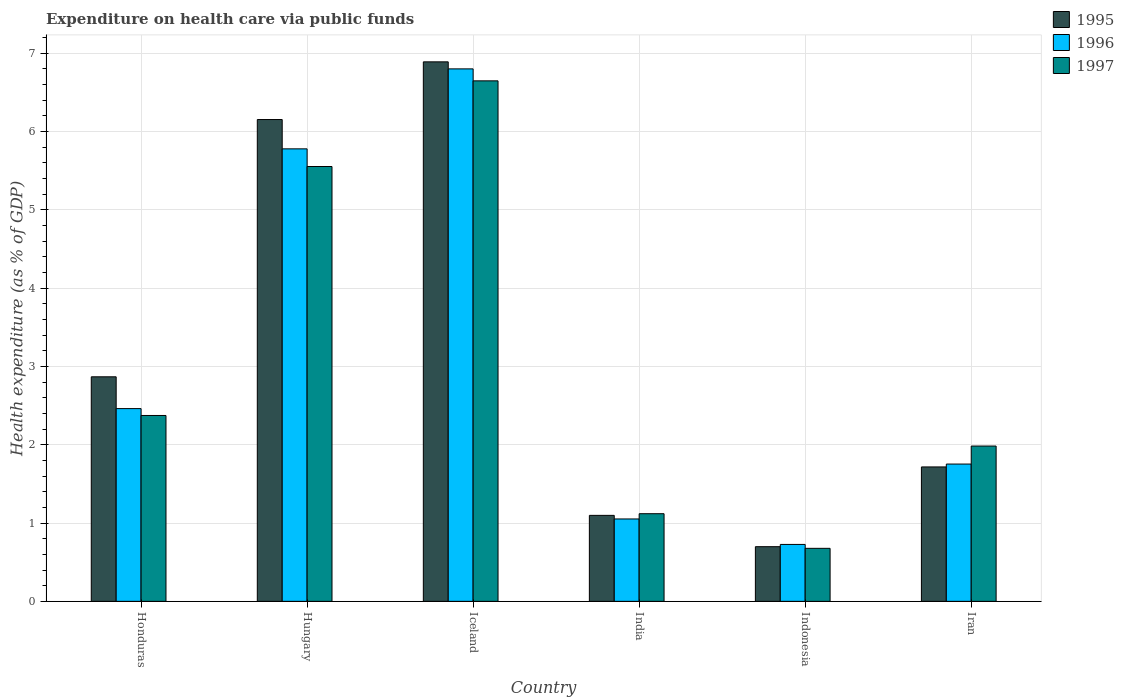How many different coloured bars are there?
Your answer should be compact. 3. How many bars are there on the 6th tick from the left?
Your answer should be compact. 3. How many bars are there on the 3rd tick from the right?
Offer a terse response. 3. What is the label of the 6th group of bars from the left?
Provide a succinct answer. Iran. In how many cases, is the number of bars for a given country not equal to the number of legend labels?
Provide a succinct answer. 0. What is the expenditure made on health care in 1996 in Hungary?
Keep it short and to the point. 5.78. Across all countries, what is the maximum expenditure made on health care in 1997?
Your response must be concise. 6.64. Across all countries, what is the minimum expenditure made on health care in 1995?
Give a very brief answer. 0.7. In which country was the expenditure made on health care in 1995 maximum?
Ensure brevity in your answer.  Iceland. In which country was the expenditure made on health care in 1997 minimum?
Offer a terse response. Indonesia. What is the total expenditure made on health care in 1996 in the graph?
Keep it short and to the point. 18.57. What is the difference between the expenditure made on health care in 1997 in India and that in Indonesia?
Ensure brevity in your answer.  0.44. What is the difference between the expenditure made on health care in 1996 in Iran and the expenditure made on health care in 1995 in India?
Give a very brief answer. 0.66. What is the average expenditure made on health care in 1997 per country?
Ensure brevity in your answer.  3.06. What is the difference between the expenditure made on health care of/in 1995 and expenditure made on health care of/in 1996 in Iran?
Make the answer very short. -0.04. What is the ratio of the expenditure made on health care in 1997 in Honduras to that in Indonesia?
Make the answer very short. 3.51. Is the expenditure made on health care in 1995 in Hungary less than that in Iceland?
Give a very brief answer. Yes. What is the difference between the highest and the second highest expenditure made on health care in 1997?
Give a very brief answer. -3.18. What is the difference between the highest and the lowest expenditure made on health care in 1997?
Provide a succinct answer. 5.97. In how many countries, is the expenditure made on health care in 1995 greater than the average expenditure made on health care in 1995 taken over all countries?
Your answer should be very brief. 2. Is it the case that in every country, the sum of the expenditure made on health care in 1996 and expenditure made on health care in 1997 is greater than the expenditure made on health care in 1995?
Give a very brief answer. Yes. Are all the bars in the graph horizontal?
Your answer should be very brief. No. How many countries are there in the graph?
Your response must be concise. 6. Does the graph contain grids?
Ensure brevity in your answer.  Yes. Where does the legend appear in the graph?
Keep it short and to the point. Top right. How many legend labels are there?
Give a very brief answer. 3. How are the legend labels stacked?
Provide a short and direct response. Vertical. What is the title of the graph?
Provide a succinct answer. Expenditure on health care via public funds. What is the label or title of the Y-axis?
Make the answer very short. Health expenditure (as % of GDP). What is the Health expenditure (as % of GDP) in 1995 in Honduras?
Provide a short and direct response. 2.87. What is the Health expenditure (as % of GDP) in 1996 in Honduras?
Your answer should be compact. 2.46. What is the Health expenditure (as % of GDP) of 1997 in Honduras?
Your answer should be compact. 2.37. What is the Health expenditure (as % of GDP) in 1995 in Hungary?
Keep it short and to the point. 6.15. What is the Health expenditure (as % of GDP) in 1996 in Hungary?
Your answer should be very brief. 5.78. What is the Health expenditure (as % of GDP) in 1997 in Hungary?
Provide a succinct answer. 5.55. What is the Health expenditure (as % of GDP) of 1995 in Iceland?
Provide a short and direct response. 6.89. What is the Health expenditure (as % of GDP) of 1996 in Iceland?
Offer a very short reply. 6.8. What is the Health expenditure (as % of GDP) of 1997 in Iceland?
Make the answer very short. 6.64. What is the Health expenditure (as % of GDP) of 1995 in India?
Keep it short and to the point. 1.1. What is the Health expenditure (as % of GDP) in 1996 in India?
Your answer should be compact. 1.05. What is the Health expenditure (as % of GDP) in 1997 in India?
Offer a terse response. 1.12. What is the Health expenditure (as % of GDP) in 1995 in Indonesia?
Ensure brevity in your answer.  0.7. What is the Health expenditure (as % of GDP) of 1996 in Indonesia?
Give a very brief answer. 0.73. What is the Health expenditure (as % of GDP) in 1997 in Indonesia?
Your answer should be very brief. 0.68. What is the Health expenditure (as % of GDP) of 1995 in Iran?
Your response must be concise. 1.72. What is the Health expenditure (as % of GDP) in 1996 in Iran?
Provide a succinct answer. 1.75. What is the Health expenditure (as % of GDP) in 1997 in Iran?
Keep it short and to the point. 1.98. Across all countries, what is the maximum Health expenditure (as % of GDP) of 1995?
Your answer should be very brief. 6.89. Across all countries, what is the maximum Health expenditure (as % of GDP) of 1996?
Ensure brevity in your answer.  6.8. Across all countries, what is the maximum Health expenditure (as % of GDP) in 1997?
Ensure brevity in your answer.  6.64. Across all countries, what is the minimum Health expenditure (as % of GDP) in 1995?
Ensure brevity in your answer.  0.7. Across all countries, what is the minimum Health expenditure (as % of GDP) of 1996?
Your answer should be compact. 0.73. Across all countries, what is the minimum Health expenditure (as % of GDP) of 1997?
Keep it short and to the point. 0.68. What is the total Health expenditure (as % of GDP) in 1995 in the graph?
Keep it short and to the point. 19.42. What is the total Health expenditure (as % of GDP) of 1996 in the graph?
Your answer should be compact. 18.57. What is the total Health expenditure (as % of GDP) in 1997 in the graph?
Your answer should be compact. 18.35. What is the difference between the Health expenditure (as % of GDP) in 1995 in Honduras and that in Hungary?
Your answer should be compact. -3.28. What is the difference between the Health expenditure (as % of GDP) of 1996 in Honduras and that in Hungary?
Your response must be concise. -3.32. What is the difference between the Health expenditure (as % of GDP) of 1997 in Honduras and that in Hungary?
Offer a very short reply. -3.18. What is the difference between the Health expenditure (as % of GDP) of 1995 in Honduras and that in Iceland?
Offer a terse response. -4.02. What is the difference between the Health expenditure (as % of GDP) of 1996 in Honduras and that in Iceland?
Offer a very short reply. -4.34. What is the difference between the Health expenditure (as % of GDP) of 1997 in Honduras and that in Iceland?
Your response must be concise. -4.27. What is the difference between the Health expenditure (as % of GDP) of 1995 in Honduras and that in India?
Offer a very short reply. 1.77. What is the difference between the Health expenditure (as % of GDP) of 1996 in Honduras and that in India?
Your response must be concise. 1.41. What is the difference between the Health expenditure (as % of GDP) in 1997 in Honduras and that in India?
Provide a succinct answer. 1.25. What is the difference between the Health expenditure (as % of GDP) of 1995 in Honduras and that in Indonesia?
Your answer should be compact. 2.17. What is the difference between the Health expenditure (as % of GDP) in 1996 in Honduras and that in Indonesia?
Provide a succinct answer. 1.73. What is the difference between the Health expenditure (as % of GDP) in 1997 in Honduras and that in Indonesia?
Provide a succinct answer. 1.7. What is the difference between the Health expenditure (as % of GDP) in 1995 in Honduras and that in Iran?
Your answer should be compact. 1.15. What is the difference between the Health expenditure (as % of GDP) in 1996 in Honduras and that in Iran?
Offer a very short reply. 0.71. What is the difference between the Health expenditure (as % of GDP) of 1997 in Honduras and that in Iran?
Ensure brevity in your answer.  0.39. What is the difference between the Health expenditure (as % of GDP) in 1995 in Hungary and that in Iceland?
Your answer should be very brief. -0.74. What is the difference between the Health expenditure (as % of GDP) in 1996 in Hungary and that in Iceland?
Ensure brevity in your answer.  -1.02. What is the difference between the Health expenditure (as % of GDP) of 1997 in Hungary and that in Iceland?
Provide a succinct answer. -1.09. What is the difference between the Health expenditure (as % of GDP) of 1995 in Hungary and that in India?
Your answer should be very brief. 5.05. What is the difference between the Health expenditure (as % of GDP) in 1996 in Hungary and that in India?
Keep it short and to the point. 4.72. What is the difference between the Health expenditure (as % of GDP) of 1997 in Hungary and that in India?
Provide a short and direct response. 4.43. What is the difference between the Health expenditure (as % of GDP) of 1995 in Hungary and that in Indonesia?
Offer a terse response. 5.45. What is the difference between the Health expenditure (as % of GDP) in 1996 in Hungary and that in Indonesia?
Keep it short and to the point. 5.05. What is the difference between the Health expenditure (as % of GDP) in 1997 in Hungary and that in Indonesia?
Offer a terse response. 4.87. What is the difference between the Health expenditure (as % of GDP) in 1995 in Hungary and that in Iran?
Provide a short and direct response. 4.43. What is the difference between the Health expenditure (as % of GDP) of 1996 in Hungary and that in Iran?
Offer a very short reply. 4.02. What is the difference between the Health expenditure (as % of GDP) in 1997 in Hungary and that in Iran?
Your response must be concise. 3.57. What is the difference between the Health expenditure (as % of GDP) of 1995 in Iceland and that in India?
Your answer should be compact. 5.79. What is the difference between the Health expenditure (as % of GDP) in 1996 in Iceland and that in India?
Keep it short and to the point. 5.75. What is the difference between the Health expenditure (as % of GDP) of 1997 in Iceland and that in India?
Provide a short and direct response. 5.53. What is the difference between the Health expenditure (as % of GDP) of 1995 in Iceland and that in Indonesia?
Your answer should be very brief. 6.19. What is the difference between the Health expenditure (as % of GDP) of 1996 in Iceland and that in Indonesia?
Offer a very short reply. 6.07. What is the difference between the Health expenditure (as % of GDP) of 1997 in Iceland and that in Indonesia?
Your answer should be compact. 5.97. What is the difference between the Health expenditure (as % of GDP) in 1995 in Iceland and that in Iran?
Provide a short and direct response. 5.17. What is the difference between the Health expenditure (as % of GDP) in 1996 in Iceland and that in Iran?
Offer a very short reply. 5.04. What is the difference between the Health expenditure (as % of GDP) of 1997 in Iceland and that in Iran?
Offer a terse response. 4.66. What is the difference between the Health expenditure (as % of GDP) in 1995 in India and that in Indonesia?
Provide a succinct answer. 0.4. What is the difference between the Health expenditure (as % of GDP) in 1996 in India and that in Indonesia?
Offer a terse response. 0.33. What is the difference between the Health expenditure (as % of GDP) in 1997 in India and that in Indonesia?
Keep it short and to the point. 0.44. What is the difference between the Health expenditure (as % of GDP) in 1995 in India and that in Iran?
Provide a succinct answer. -0.62. What is the difference between the Health expenditure (as % of GDP) of 1996 in India and that in Iran?
Your answer should be compact. -0.7. What is the difference between the Health expenditure (as % of GDP) of 1997 in India and that in Iran?
Provide a succinct answer. -0.86. What is the difference between the Health expenditure (as % of GDP) of 1995 in Indonesia and that in Iran?
Provide a succinct answer. -1.02. What is the difference between the Health expenditure (as % of GDP) in 1996 in Indonesia and that in Iran?
Offer a terse response. -1.03. What is the difference between the Health expenditure (as % of GDP) of 1997 in Indonesia and that in Iran?
Provide a short and direct response. -1.31. What is the difference between the Health expenditure (as % of GDP) in 1995 in Honduras and the Health expenditure (as % of GDP) in 1996 in Hungary?
Your answer should be compact. -2.91. What is the difference between the Health expenditure (as % of GDP) in 1995 in Honduras and the Health expenditure (as % of GDP) in 1997 in Hungary?
Make the answer very short. -2.68. What is the difference between the Health expenditure (as % of GDP) of 1996 in Honduras and the Health expenditure (as % of GDP) of 1997 in Hungary?
Provide a succinct answer. -3.09. What is the difference between the Health expenditure (as % of GDP) of 1995 in Honduras and the Health expenditure (as % of GDP) of 1996 in Iceland?
Ensure brevity in your answer.  -3.93. What is the difference between the Health expenditure (as % of GDP) in 1995 in Honduras and the Health expenditure (as % of GDP) in 1997 in Iceland?
Your answer should be very brief. -3.78. What is the difference between the Health expenditure (as % of GDP) of 1996 in Honduras and the Health expenditure (as % of GDP) of 1997 in Iceland?
Make the answer very short. -4.18. What is the difference between the Health expenditure (as % of GDP) of 1995 in Honduras and the Health expenditure (as % of GDP) of 1996 in India?
Provide a short and direct response. 1.81. What is the difference between the Health expenditure (as % of GDP) in 1995 in Honduras and the Health expenditure (as % of GDP) in 1997 in India?
Offer a terse response. 1.75. What is the difference between the Health expenditure (as % of GDP) in 1996 in Honduras and the Health expenditure (as % of GDP) in 1997 in India?
Your answer should be compact. 1.34. What is the difference between the Health expenditure (as % of GDP) of 1995 in Honduras and the Health expenditure (as % of GDP) of 1996 in Indonesia?
Offer a terse response. 2.14. What is the difference between the Health expenditure (as % of GDP) of 1995 in Honduras and the Health expenditure (as % of GDP) of 1997 in Indonesia?
Your answer should be compact. 2.19. What is the difference between the Health expenditure (as % of GDP) in 1996 in Honduras and the Health expenditure (as % of GDP) in 1997 in Indonesia?
Provide a succinct answer. 1.78. What is the difference between the Health expenditure (as % of GDP) of 1995 in Honduras and the Health expenditure (as % of GDP) of 1996 in Iran?
Offer a very short reply. 1.11. What is the difference between the Health expenditure (as % of GDP) in 1995 in Honduras and the Health expenditure (as % of GDP) in 1997 in Iran?
Provide a short and direct response. 0.88. What is the difference between the Health expenditure (as % of GDP) in 1996 in Honduras and the Health expenditure (as % of GDP) in 1997 in Iran?
Your answer should be very brief. 0.48. What is the difference between the Health expenditure (as % of GDP) in 1995 in Hungary and the Health expenditure (as % of GDP) in 1996 in Iceland?
Make the answer very short. -0.65. What is the difference between the Health expenditure (as % of GDP) of 1995 in Hungary and the Health expenditure (as % of GDP) of 1997 in Iceland?
Provide a short and direct response. -0.49. What is the difference between the Health expenditure (as % of GDP) in 1996 in Hungary and the Health expenditure (as % of GDP) in 1997 in Iceland?
Your answer should be compact. -0.87. What is the difference between the Health expenditure (as % of GDP) in 1995 in Hungary and the Health expenditure (as % of GDP) in 1996 in India?
Keep it short and to the point. 5.1. What is the difference between the Health expenditure (as % of GDP) of 1995 in Hungary and the Health expenditure (as % of GDP) of 1997 in India?
Provide a succinct answer. 5.03. What is the difference between the Health expenditure (as % of GDP) of 1996 in Hungary and the Health expenditure (as % of GDP) of 1997 in India?
Offer a very short reply. 4.66. What is the difference between the Health expenditure (as % of GDP) in 1995 in Hungary and the Health expenditure (as % of GDP) in 1996 in Indonesia?
Your answer should be very brief. 5.42. What is the difference between the Health expenditure (as % of GDP) in 1995 in Hungary and the Health expenditure (as % of GDP) in 1997 in Indonesia?
Keep it short and to the point. 5.47. What is the difference between the Health expenditure (as % of GDP) in 1996 in Hungary and the Health expenditure (as % of GDP) in 1997 in Indonesia?
Give a very brief answer. 5.1. What is the difference between the Health expenditure (as % of GDP) of 1995 in Hungary and the Health expenditure (as % of GDP) of 1996 in Iran?
Offer a very short reply. 4.4. What is the difference between the Health expenditure (as % of GDP) of 1995 in Hungary and the Health expenditure (as % of GDP) of 1997 in Iran?
Ensure brevity in your answer.  4.17. What is the difference between the Health expenditure (as % of GDP) of 1996 in Hungary and the Health expenditure (as % of GDP) of 1997 in Iran?
Provide a succinct answer. 3.79. What is the difference between the Health expenditure (as % of GDP) of 1995 in Iceland and the Health expenditure (as % of GDP) of 1996 in India?
Provide a succinct answer. 5.84. What is the difference between the Health expenditure (as % of GDP) of 1995 in Iceland and the Health expenditure (as % of GDP) of 1997 in India?
Your response must be concise. 5.77. What is the difference between the Health expenditure (as % of GDP) of 1996 in Iceland and the Health expenditure (as % of GDP) of 1997 in India?
Your answer should be very brief. 5.68. What is the difference between the Health expenditure (as % of GDP) of 1995 in Iceland and the Health expenditure (as % of GDP) of 1996 in Indonesia?
Keep it short and to the point. 6.16. What is the difference between the Health expenditure (as % of GDP) in 1995 in Iceland and the Health expenditure (as % of GDP) in 1997 in Indonesia?
Offer a very short reply. 6.21. What is the difference between the Health expenditure (as % of GDP) in 1996 in Iceland and the Health expenditure (as % of GDP) in 1997 in Indonesia?
Ensure brevity in your answer.  6.12. What is the difference between the Health expenditure (as % of GDP) of 1995 in Iceland and the Health expenditure (as % of GDP) of 1996 in Iran?
Provide a succinct answer. 5.13. What is the difference between the Health expenditure (as % of GDP) of 1995 in Iceland and the Health expenditure (as % of GDP) of 1997 in Iran?
Give a very brief answer. 4.9. What is the difference between the Health expenditure (as % of GDP) of 1996 in Iceland and the Health expenditure (as % of GDP) of 1997 in Iran?
Offer a very short reply. 4.81. What is the difference between the Health expenditure (as % of GDP) in 1995 in India and the Health expenditure (as % of GDP) in 1996 in Indonesia?
Offer a terse response. 0.37. What is the difference between the Health expenditure (as % of GDP) in 1995 in India and the Health expenditure (as % of GDP) in 1997 in Indonesia?
Provide a succinct answer. 0.42. What is the difference between the Health expenditure (as % of GDP) of 1996 in India and the Health expenditure (as % of GDP) of 1997 in Indonesia?
Make the answer very short. 0.38. What is the difference between the Health expenditure (as % of GDP) of 1995 in India and the Health expenditure (as % of GDP) of 1996 in Iran?
Give a very brief answer. -0.66. What is the difference between the Health expenditure (as % of GDP) of 1995 in India and the Health expenditure (as % of GDP) of 1997 in Iran?
Offer a terse response. -0.89. What is the difference between the Health expenditure (as % of GDP) in 1996 in India and the Health expenditure (as % of GDP) in 1997 in Iran?
Your answer should be very brief. -0.93. What is the difference between the Health expenditure (as % of GDP) of 1995 in Indonesia and the Health expenditure (as % of GDP) of 1996 in Iran?
Your answer should be compact. -1.05. What is the difference between the Health expenditure (as % of GDP) of 1995 in Indonesia and the Health expenditure (as % of GDP) of 1997 in Iran?
Keep it short and to the point. -1.28. What is the difference between the Health expenditure (as % of GDP) of 1996 in Indonesia and the Health expenditure (as % of GDP) of 1997 in Iran?
Your answer should be compact. -1.26. What is the average Health expenditure (as % of GDP) of 1995 per country?
Provide a succinct answer. 3.24. What is the average Health expenditure (as % of GDP) of 1996 per country?
Your answer should be very brief. 3.09. What is the average Health expenditure (as % of GDP) of 1997 per country?
Your response must be concise. 3.06. What is the difference between the Health expenditure (as % of GDP) in 1995 and Health expenditure (as % of GDP) in 1996 in Honduras?
Offer a very short reply. 0.41. What is the difference between the Health expenditure (as % of GDP) of 1995 and Health expenditure (as % of GDP) of 1997 in Honduras?
Your answer should be very brief. 0.49. What is the difference between the Health expenditure (as % of GDP) of 1996 and Health expenditure (as % of GDP) of 1997 in Honduras?
Offer a terse response. 0.09. What is the difference between the Health expenditure (as % of GDP) of 1995 and Health expenditure (as % of GDP) of 1996 in Hungary?
Your answer should be very brief. 0.37. What is the difference between the Health expenditure (as % of GDP) in 1995 and Health expenditure (as % of GDP) in 1997 in Hungary?
Your answer should be very brief. 0.6. What is the difference between the Health expenditure (as % of GDP) in 1996 and Health expenditure (as % of GDP) in 1997 in Hungary?
Give a very brief answer. 0.23. What is the difference between the Health expenditure (as % of GDP) in 1995 and Health expenditure (as % of GDP) in 1996 in Iceland?
Keep it short and to the point. 0.09. What is the difference between the Health expenditure (as % of GDP) in 1995 and Health expenditure (as % of GDP) in 1997 in Iceland?
Keep it short and to the point. 0.24. What is the difference between the Health expenditure (as % of GDP) of 1996 and Health expenditure (as % of GDP) of 1997 in Iceland?
Your answer should be compact. 0.15. What is the difference between the Health expenditure (as % of GDP) in 1995 and Health expenditure (as % of GDP) in 1996 in India?
Ensure brevity in your answer.  0.05. What is the difference between the Health expenditure (as % of GDP) in 1995 and Health expenditure (as % of GDP) in 1997 in India?
Make the answer very short. -0.02. What is the difference between the Health expenditure (as % of GDP) in 1996 and Health expenditure (as % of GDP) in 1997 in India?
Your answer should be compact. -0.07. What is the difference between the Health expenditure (as % of GDP) of 1995 and Health expenditure (as % of GDP) of 1996 in Indonesia?
Provide a short and direct response. -0.03. What is the difference between the Health expenditure (as % of GDP) in 1995 and Health expenditure (as % of GDP) in 1997 in Indonesia?
Offer a terse response. 0.02. What is the difference between the Health expenditure (as % of GDP) in 1996 and Health expenditure (as % of GDP) in 1997 in Indonesia?
Your answer should be very brief. 0.05. What is the difference between the Health expenditure (as % of GDP) of 1995 and Health expenditure (as % of GDP) of 1996 in Iran?
Provide a succinct answer. -0.04. What is the difference between the Health expenditure (as % of GDP) of 1995 and Health expenditure (as % of GDP) of 1997 in Iran?
Your answer should be very brief. -0.27. What is the difference between the Health expenditure (as % of GDP) in 1996 and Health expenditure (as % of GDP) in 1997 in Iran?
Offer a very short reply. -0.23. What is the ratio of the Health expenditure (as % of GDP) of 1995 in Honduras to that in Hungary?
Your answer should be very brief. 0.47. What is the ratio of the Health expenditure (as % of GDP) in 1996 in Honduras to that in Hungary?
Your response must be concise. 0.43. What is the ratio of the Health expenditure (as % of GDP) of 1997 in Honduras to that in Hungary?
Offer a terse response. 0.43. What is the ratio of the Health expenditure (as % of GDP) of 1995 in Honduras to that in Iceland?
Ensure brevity in your answer.  0.42. What is the ratio of the Health expenditure (as % of GDP) in 1996 in Honduras to that in Iceland?
Provide a succinct answer. 0.36. What is the ratio of the Health expenditure (as % of GDP) of 1997 in Honduras to that in Iceland?
Your answer should be very brief. 0.36. What is the ratio of the Health expenditure (as % of GDP) in 1995 in Honduras to that in India?
Your answer should be very brief. 2.61. What is the ratio of the Health expenditure (as % of GDP) of 1996 in Honduras to that in India?
Provide a short and direct response. 2.34. What is the ratio of the Health expenditure (as % of GDP) of 1997 in Honduras to that in India?
Give a very brief answer. 2.12. What is the ratio of the Health expenditure (as % of GDP) of 1995 in Honduras to that in Indonesia?
Your answer should be very brief. 4.11. What is the ratio of the Health expenditure (as % of GDP) in 1996 in Honduras to that in Indonesia?
Ensure brevity in your answer.  3.39. What is the ratio of the Health expenditure (as % of GDP) of 1997 in Honduras to that in Indonesia?
Ensure brevity in your answer.  3.51. What is the ratio of the Health expenditure (as % of GDP) in 1995 in Honduras to that in Iran?
Ensure brevity in your answer.  1.67. What is the ratio of the Health expenditure (as % of GDP) of 1996 in Honduras to that in Iran?
Your answer should be compact. 1.4. What is the ratio of the Health expenditure (as % of GDP) of 1997 in Honduras to that in Iran?
Make the answer very short. 1.2. What is the ratio of the Health expenditure (as % of GDP) of 1995 in Hungary to that in Iceland?
Make the answer very short. 0.89. What is the ratio of the Health expenditure (as % of GDP) in 1996 in Hungary to that in Iceland?
Offer a terse response. 0.85. What is the ratio of the Health expenditure (as % of GDP) of 1997 in Hungary to that in Iceland?
Provide a succinct answer. 0.84. What is the ratio of the Health expenditure (as % of GDP) of 1995 in Hungary to that in India?
Provide a short and direct response. 5.6. What is the ratio of the Health expenditure (as % of GDP) of 1996 in Hungary to that in India?
Provide a succinct answer. 5.49. What is the ratio of the Health expenditure (as % of GDP) of 1997 in Hungary to that in India?
Make the answer very short. 4.96. What is the ratio of the Health expenditure (as % of GDP) of 1995 in Hungary to that in Indonesia?
Offer a terse response. 8.81. What is the ratio of the Health expenditure (as % of GDP) of 1996 in Hungary to that in Indonesia?
Make the answer very short. 7.95. What is the ratio of the Health expenditure (as % of GDP) in 1997 in Hungary to that in Indonesia?
Provide a succinct answer. 8.2. What is the ratio of the Health expenditure (as % of GDP) in 1995 in Hungary to that in Iran?
Offer a very short reply. 3.58. What is the ratio of the Health expenditure (as % of GDP) in 1996 in Hungary to that in Iran?
Your answer should be compact. 3.3. What is the ratio of the Health expenditure (as % of GDP) of 1997 in Hungary to that in Iran?
Offer a terse response. 2.8. What is the ratio of the Health expenditure (as % of GDP) in 1995 in Iceland to that in India?
Keep it short and to the point. 6.27. What is the ratio of the Health expenditure (as % of GDP) of 1996 in Iceland to that in India?
Your answer should be compact. 6.46. What is the ratio of the Health expenditure (as % of GDP) in 1997 in Iceland to that in India?
Give a very brief answer. 5.94. What is the ratio of the Health expenditure (as % of GDP) in 1995 in Iceland to that in Indonesia?
Ensure brevity in your answer.  9.87. What is the ratio of the Health expenditure (as % of GDP) of 1996 in Iceland to that in Indonesia?
Provide a succinct answer. 9.35. What is the ratio of the Health expenditure (as % of GDP) of 1997 in Iceland to that in Indonesia?
Offer a terse response. 9.82. What is the ratio of the Health expenditure (as % of GDP) of 1995 in Iceland to that in Iran?
Offer a terse response. 4.01. What is the ratio of the Health expenditure (as % of GDP) in 1996 in Iceland to that in Iran?
Provide a short and direct response. 3.88. What is the ratio of the Health expenditure (as % of GDP) in 1997 in Iceland to that in Iran?
Ensure brevity in your answer.  3.35. What is the ratio of the Health expenditure (as % of GDP) in 1995 in India to that in Indonesia?
Keep it short and to the point. 1.57. What is the ratio of the Health expenditure (as % of GDP) in 1996 in India to that in Indonesia?
Your answer should be very brief. 1.45. What is the ratio of the Health expenditure (as % of GDP) of 1997 in India to that in Indonesia?
Ensure brevity in your answer.  1.65. What is the ratio of the Health expenditure (as % of GDP) of 1995 in India to that in Iran?
Give a very brief answer. 0.64. What is the ratio of the Health expenditure (as % of GDP) in 1996 in India to that in Iran?
Your response must be concise. 0.6. What is the ratio of the Health expenditure (as % of GDP) in 1997 in India to that in Iran?
Keep it short and to the point. 0.56. What is the ratio of the Health expenditure (as % of GDP) in 1995 in Indonesia to that in Iran?
Offer a very short reply. 0.41. What is the ratio of the Health expenditure (as % of GDP) in 1996 in Indonesia to that in Iran?
Provide a short and direct response. 0.41. What is the ratio of the Health expenditure (as % of GDP) in 1997 in Indonesia to that in Iran?
Make the answer very short. 0.34. What is the difference between the highest and the second highest Health expenditure (as % of GDP) of 1995?
Your response must be concise. 0.74. What is the difference between the highest and the second highest Health expenditure (as % of GDP) of 1996?
Offer a very short reply. 1.02. What is the difference between the highest and the second highest Health expenditure (as % of GDP) of 1997?
Give a very brief answer. 1.09. What is the difference between the highest and the lowest Health expenditure (as % of GDP) of 1995?
Ensure brevity in your answer.  6.19. What is the difference between the highest and the lowest Health expenditure (as % of GDP) of 1996?
Make the answer very short. 6.07. What is the difference between the highest and the lowest Health expenditure (as % of GDP) in 1997?
Offer a terse response. 5.97. 